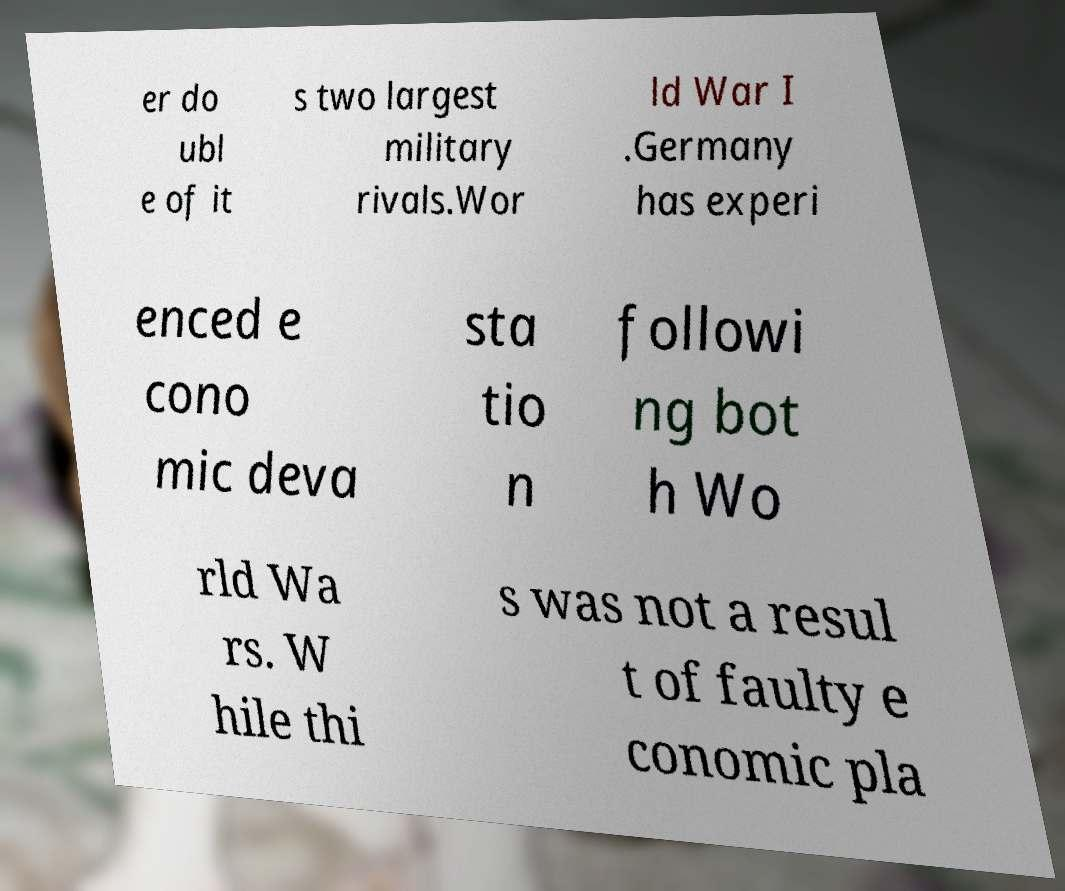I need the written content from this picture converted into text. Can you do that? er do ubl e of it s two largest military rivals.Wor ld War I .Germany has experi enced e cono mic deva sta tio n followi ng bot h Wo rld Wa rs. W hile thi s was not a resul t of faulty e conomic pla 